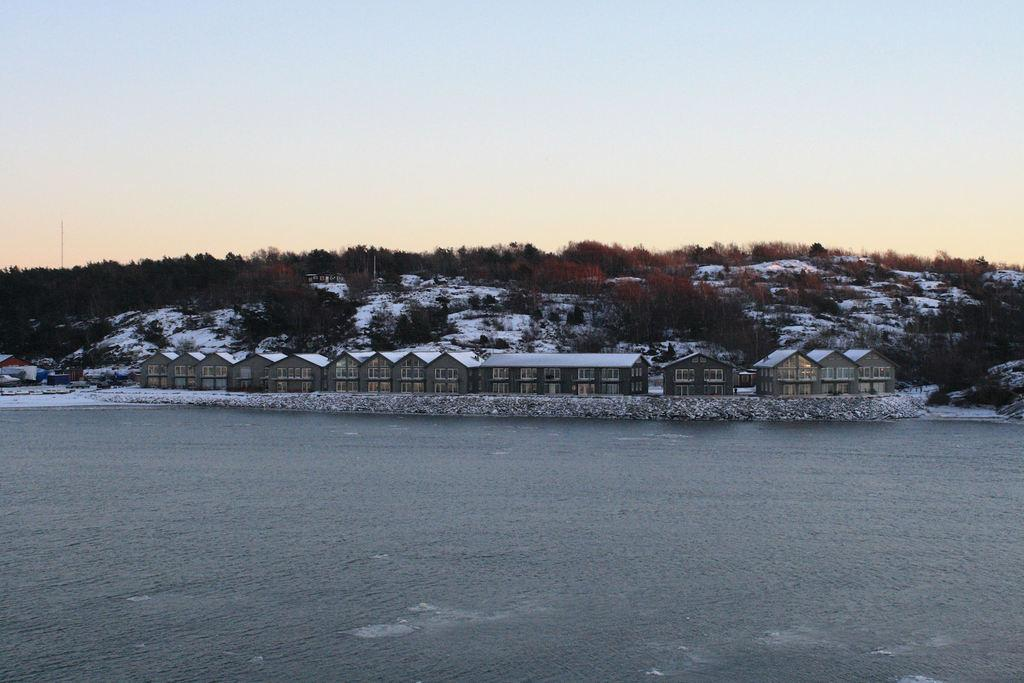What is visible in the foreground of the image? In the foreground of the image, there is water, fencehouses, snow, trees, and poles. What can be seen in the background of the image? In the background of the image, there are mountains. What is visible at the top of the image? The sky is visible at the top of the image. What might be the location of the image? The image may have been taken near a lake, as suggested by the presence of water in the foreground. How many frogs are sitting on the poles in the image? There are no frogs present in the image; it features water, fencehouses, snow, trees, poles, mountains, and the sky. What type of agreement is being made between the trees in the image? There is no agreement being made between the trees in the image; they are simply standing in the foreground. 